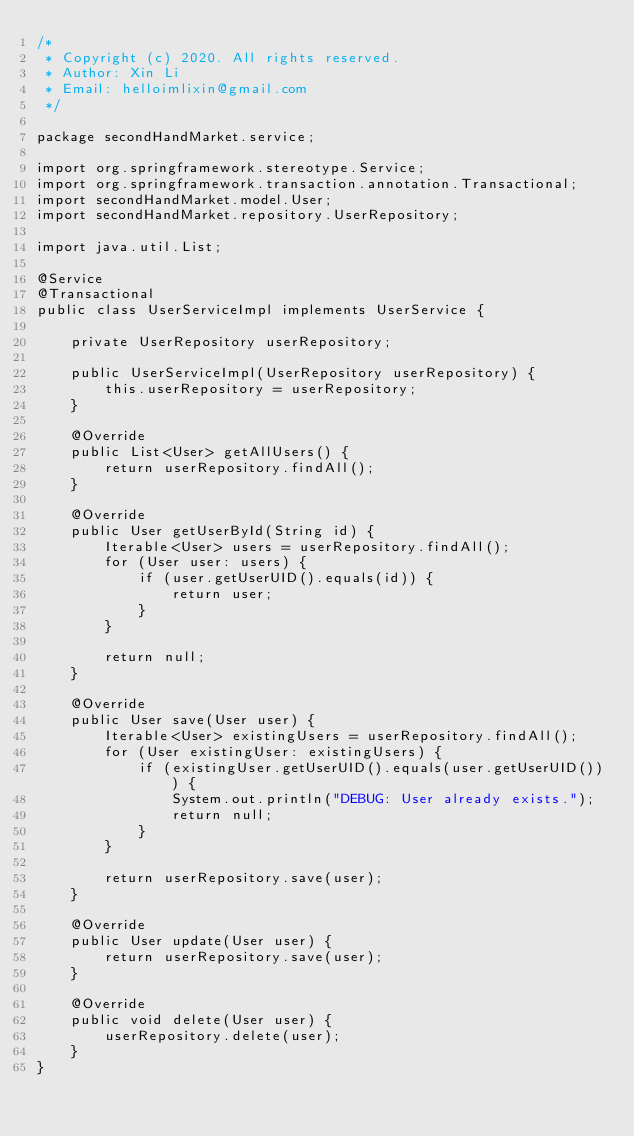Convert code to text. <code><loc_0><loc_0><loc_500><loc_500><_Java_>/*
 * Copyright (c) 2020. All rights reserved.
 * Author: Xin Li
 * Email: helloimlixin@gmail.com
 */

package secondHandMarket.service;

import org.springframework.stereotype.Service;
import org.springframework.transaction.annotation.Transactional;
import secondHandMarket.model.User;
import secondHandMarket.repository.UserRepository;

import java.util.List;

@Service
@Transactional
public class UserServiceImpl implements UserService {

    private UserRepository userRepository;

    public UserServiceImpl(UserRepository userRepository) {
        this.userRepository = userRepository;
    }

    @Override
    public List<User> getAllUsers() {
        return userRepository.findAll();
    }

    @Override
    public User getUserById(String id) {
        Iterable<User> users = userRepository.findAll();
        for (User user: users) {
            if (user.getUserUID().equals(id)) {
                return user;
            }
        }

        return null;
    }

    @Override
    public User save(User user) {
        Iterable<User> existingUsers = userRepository.findAll();
        for (User existingUser: existingUsers) {
            if (existingUser.getUserUID().equals(user.getUserUID())) {
                System.out.println("DEBUG: User already exists.");
                return null;
            }
        }

        return userRepository.save(user);
    }

    @Override
    public User update(User user) {
        return userRepository.save(user);
    }

    @Override
    public void delete(User user) {
        userRepository.delete(user);
    }
}
</code> 